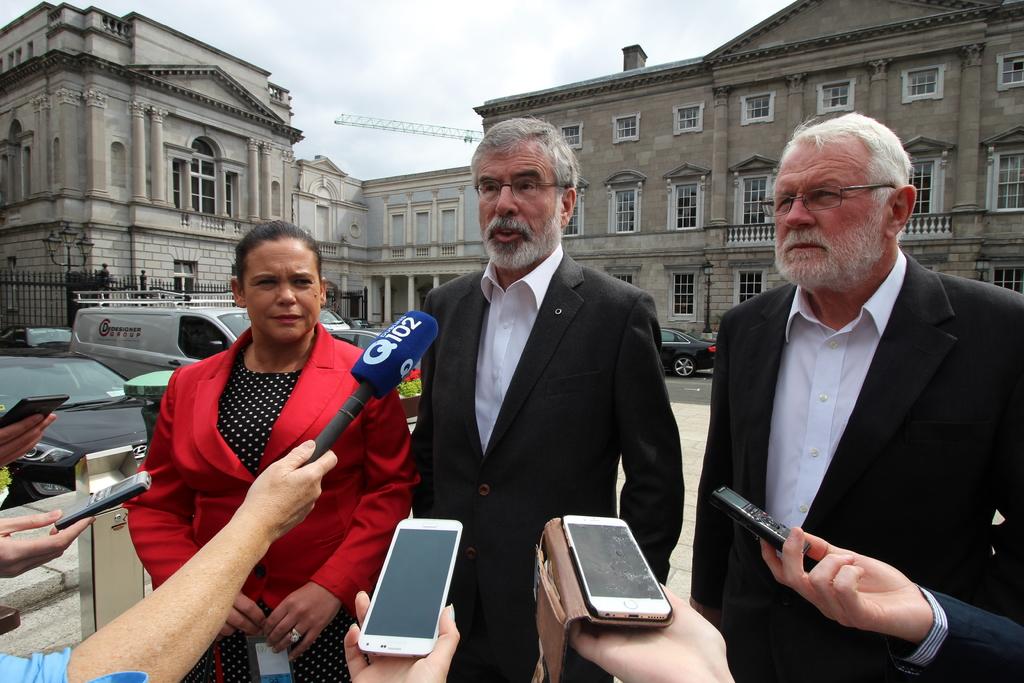What station does the blue mic belong to?
Offer a terse response. Q102. Are there at least five hands in this picture?
Provide a short and direct response. Answering does not require reading text in the image. 